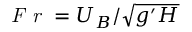Convert formula to latex. <formula><loc_0><loc_0><loc_500><loc_500>F r = { U } _ { B } / \sqrt { g ^ { \prime } H }</formula> 